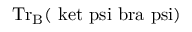<formula> <loc_0><loc_0><loc_500><loc_500>{ T r } _ { B } ( \ k e t { \ p s i } \ b r a { \ p s i } )</formula> 